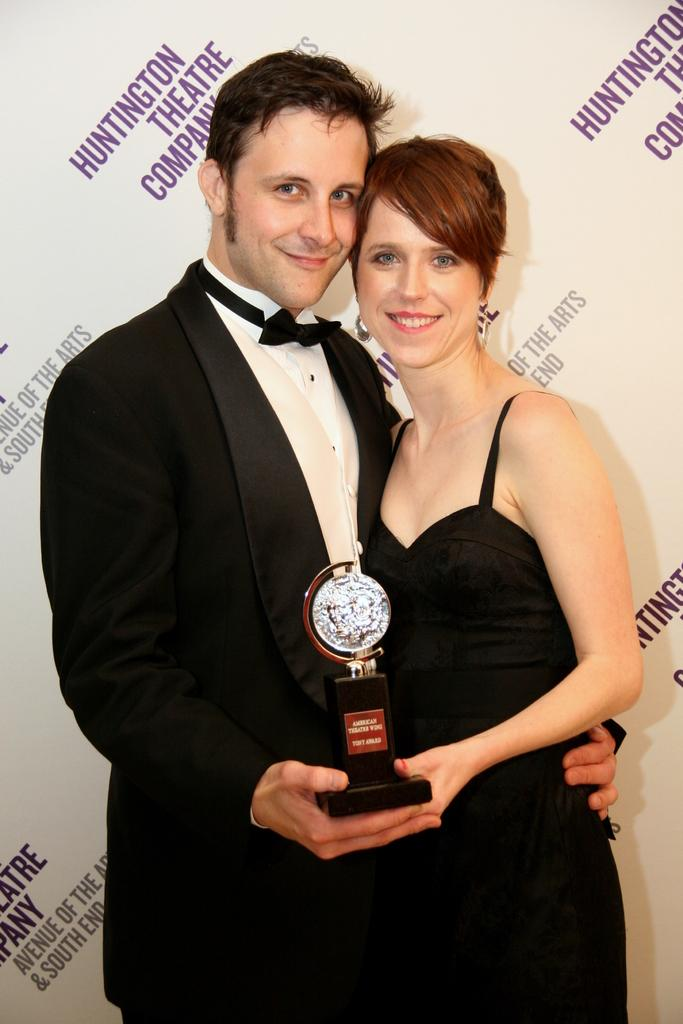<image>
Present a compact description of the photo's key features. Man with Woman that are sharing an award together and getting their picture taken, Sponsored by the Huntington Theater Company. 